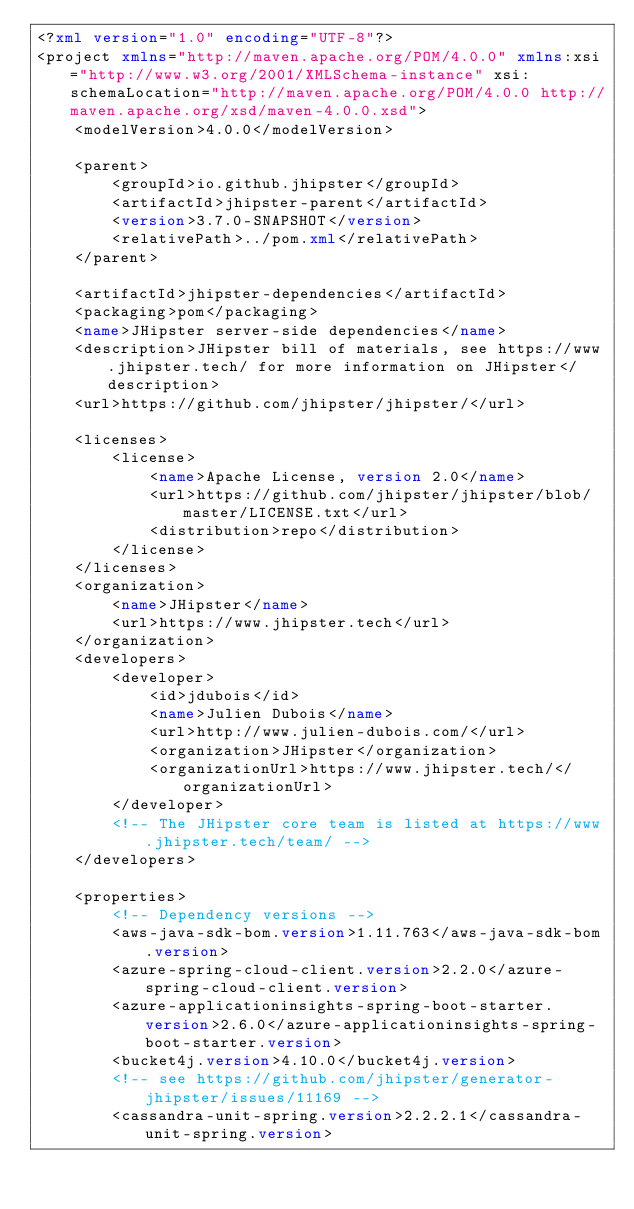Convert code to text. <code><loc_0><loc_0><loc_500><loc_500><_XML_><?xml version="1.0" encoding="UTF-8"?>
<project xmlns="http://maven.apache.org/POM/4.0.0" xmlns:xsi="http://www.w3.org/2001/XMLSchema-instance" xsi:schemaLocation="http://maven.apache.org/POM/4.0.0 http://maven.apache.org/xsd/maven-4.0.0.xsd">
    <modelVersion>4.0.0</modelVersion>

    <parent>
        <groupId>io.github.jhipster</groupId>
        <artifactId>jhipster-parent</artifactId>
        <version>3.7.0-SNAPSHOT</version>
        <relativePath>../pom.xml</relativePath>
    </parent>

    <artifactId>jhipster-dependencies</artifactId>
    <packaging>pom</packaging>
    <name>JHipster server-side dependencies</name>
    <description>JHipster bill of materials, see https://www.jhipster.tech/ for more information on JHipster</description>
    <url>https://github.com/jhipster/jhipster/</url>

    <licenses>
        <license>
            <name>Apache License, version 2.0</name>
            <url>https://github.com/jhipster/jhipster/blob/master/LICENSE.txt</url>
            <distribution>repo</distribution>
        </license>
    </licenses>
    <organization>
        <name>JHipster</name>
        <url>https://www.jhipster.tech</url>
    </organization>
    <developers>
        <developer>
            <id>jdubois</id>
            <name>Julien Dubois</name>
            <url>http://www.julien-dubois.com/</url>
            <organization>JHipster</organization>
            <organizationUrl>https://www.jhipster.tech/</organizationUrl>
        </developer>
        <!-- The JHipster core team is listed at https://www.jhipster.tech/team/ -->
    </developers>

    <properties>
        <!-- Dependency versions -->
        <aws-java-sdk-bom.version>1.11.763</aws-java-sdk-bom.version>
        <azure-spring-cloud-client.version>2.2.0</azure-spring-cloud-client.version>
        <azure-applicationinsights-spring-boot-starter.version>2.6.0</azure-applicationinsights-spring-boot-starter.version>
        <bucket4j.version>4.10.0</bucket4j.version>
        <!-- see https://github.com/jhipster/generator-jhipster/issues/11169 -->
        <cassandra-unit-spring.version>2.2.2.1</cassandra-unit-spring.version></code> 